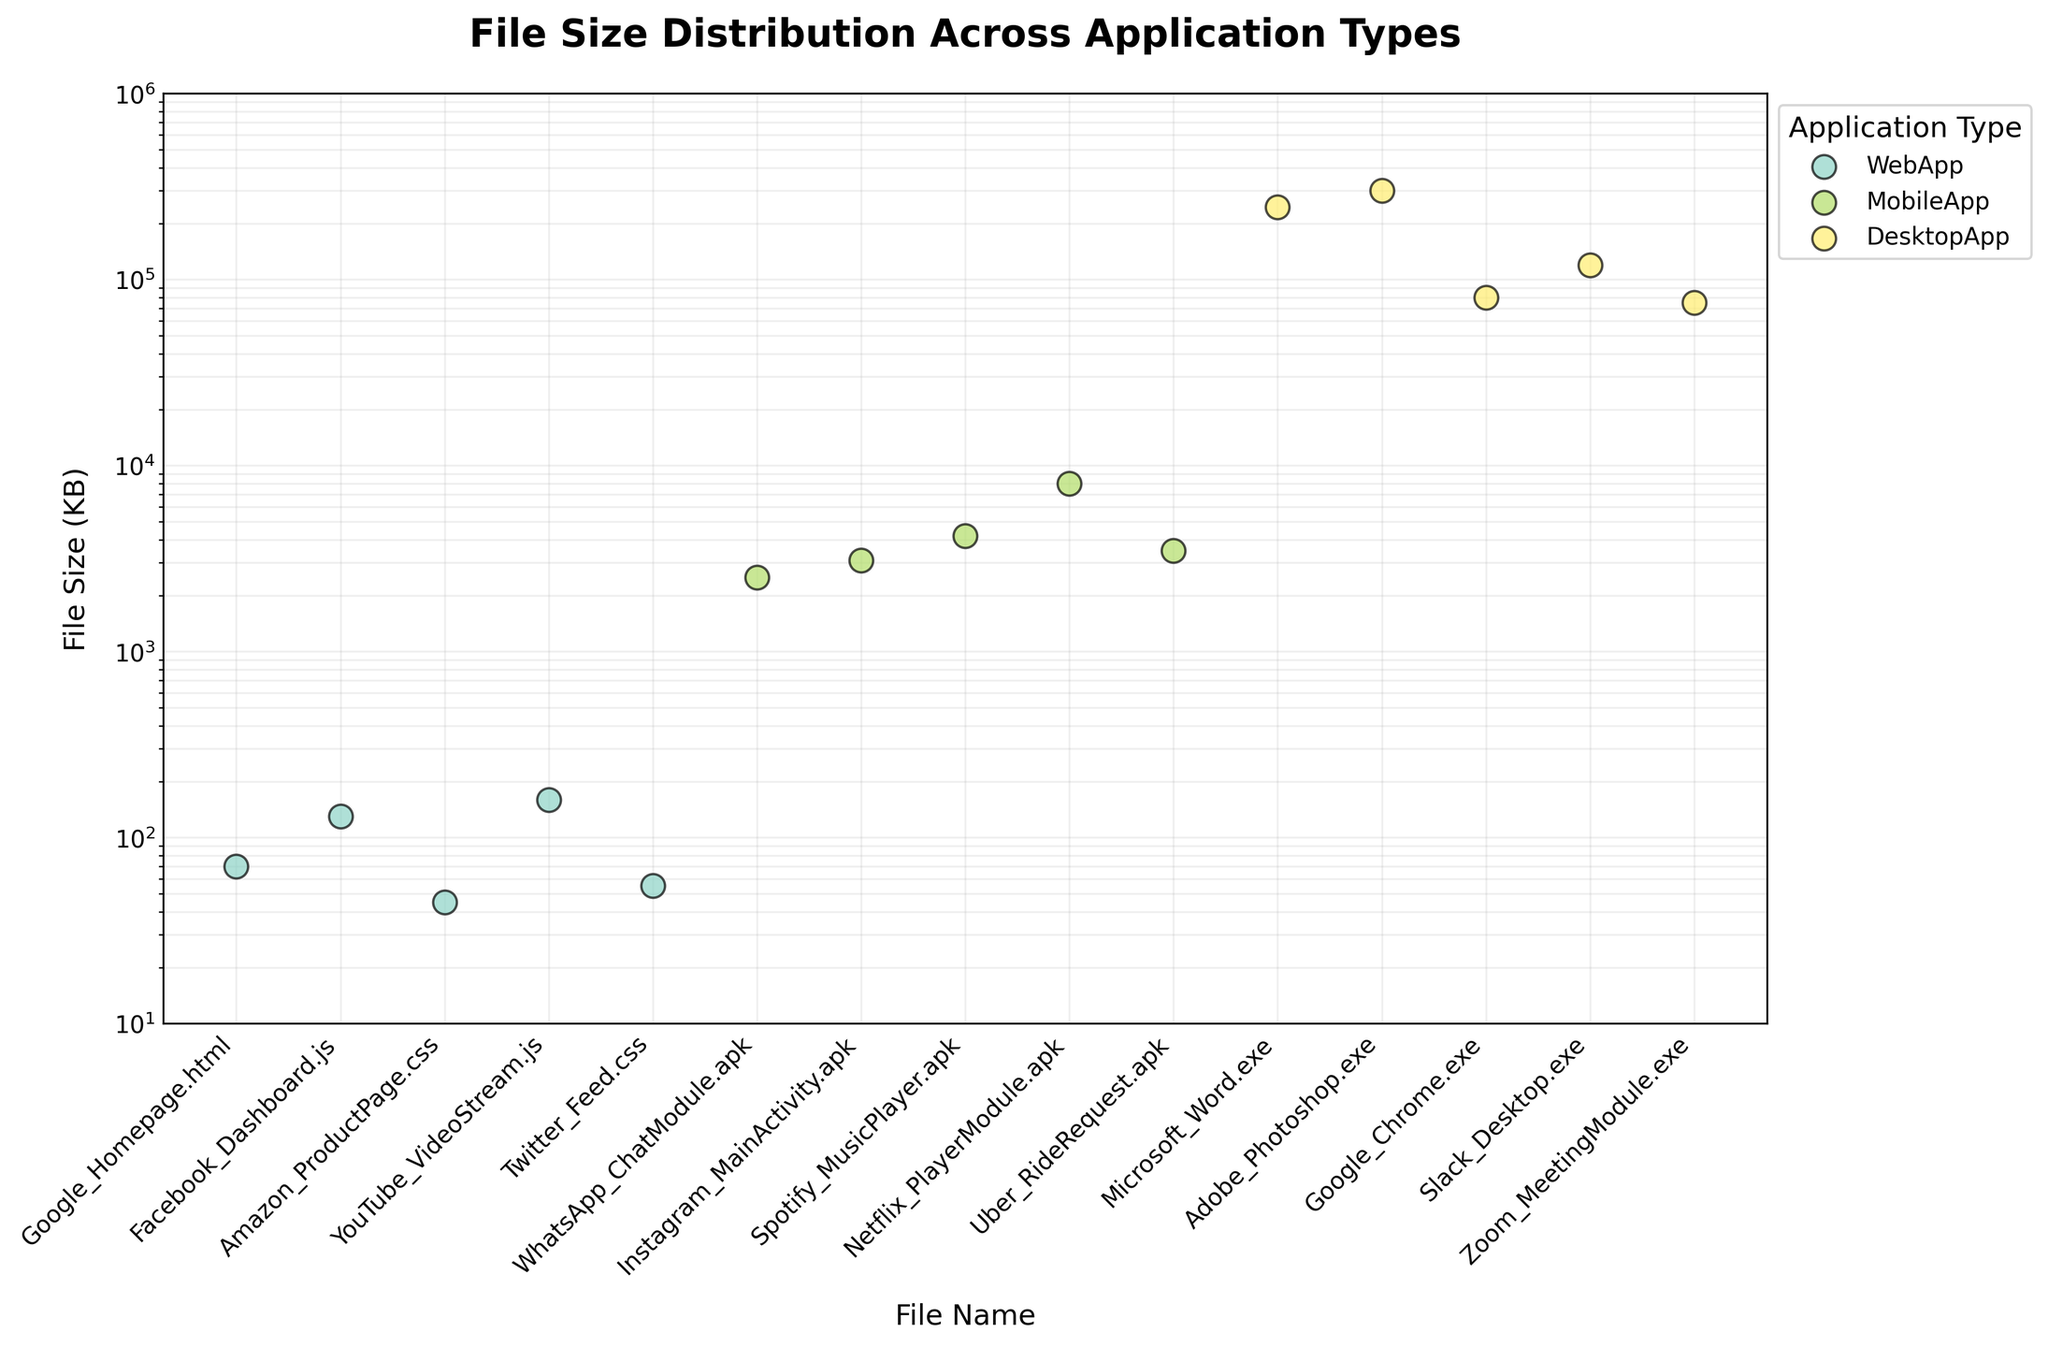what is the title of the figure? The title of the figure is displayed at the top and is often in a larger font size than other text elements, making it easy to identify. In this case, it states the content clearly.
Answer: File Size Distribution Across Application Types how many types of applications are represented in the plot? By looking at the legend on the subplot, you can identify the number of different categories listed. Each type of application is usually in a different color. The legend indicates three application types.
Answer: 3 what is the file size of the largest desktop application in the plot? Locate the points corresponding to the DesktopApp category in the subplot, and look for the one that has the highest position on the y-axis. DesktopApp is represented by the highest points in the plot; Microsoft Word.exe has the largest file size.
Answer: 300000 KB which has a larger file size, the YouTube_VideoStream.js (WebApp) file or the Uber_RideRequest.apk (MobileApp) file? To determine which file is larger, locate both files on the x-axis and compare their y-axis values. The YouTube_VideoStream.js point is lower on the y-axis than the Uber_RideRequest.apk point, indicating a smaller size.
Answer: Uber_RideRequest.apk what is the range of file sizes for MobileApp in the plot? To find the range, identify the smallest and largest y-axis values for the MobileApp category. The lowest point is WhatsApp_ChatModule.apk with 2500 KB, and the highest is Netflix_PlayerModule.apk with 8000 KB. Calculate the difference between these two values to get the range.
Answer: 2500 KB to 8000 KB which has fewer data points, WebApp or DesktopApp? Count the number of points representing each application type in the subplot. WebApp has 5 data points and DesktopApp also has 5 data points.
Answer: Equal what is the file size difference between the smallest WebApp file and the smallest DesktopApp file? Identify the data points with the smallest y-axis values for both WebApp and DesktopApp. The smallest WebApp file is Amazon_ProductPage.css at 45 KB, and the smallest DesktopApp file is Zoom_MeetingModule.exe at 75000 KB. Subtract the WebApp size from the DesktopApp size to find the difference.
Answer: 74955 KB is there any overlap in the file size ranges of WebApp and DesktopApp categories? Analyze the y-axis values to see if any file sizes from the WebApp category fall within the range of the DesktopApp category. WebApp files range from 45 KB to 160 KB, while DesktopApp files range from 75000 KB to 300000 KB. There is no overlap as the smallest DesktopApp file is much larger than the largest WebApp file.
Answer: No which application type has the most diverse range of file sizes? Compare the ranges of file sizes between the application types by evaluating the spread on the y-axis of each category. DesktopApp has the broadest range from 75000 KB to 300000 KB.
Answer: DesktopApp 